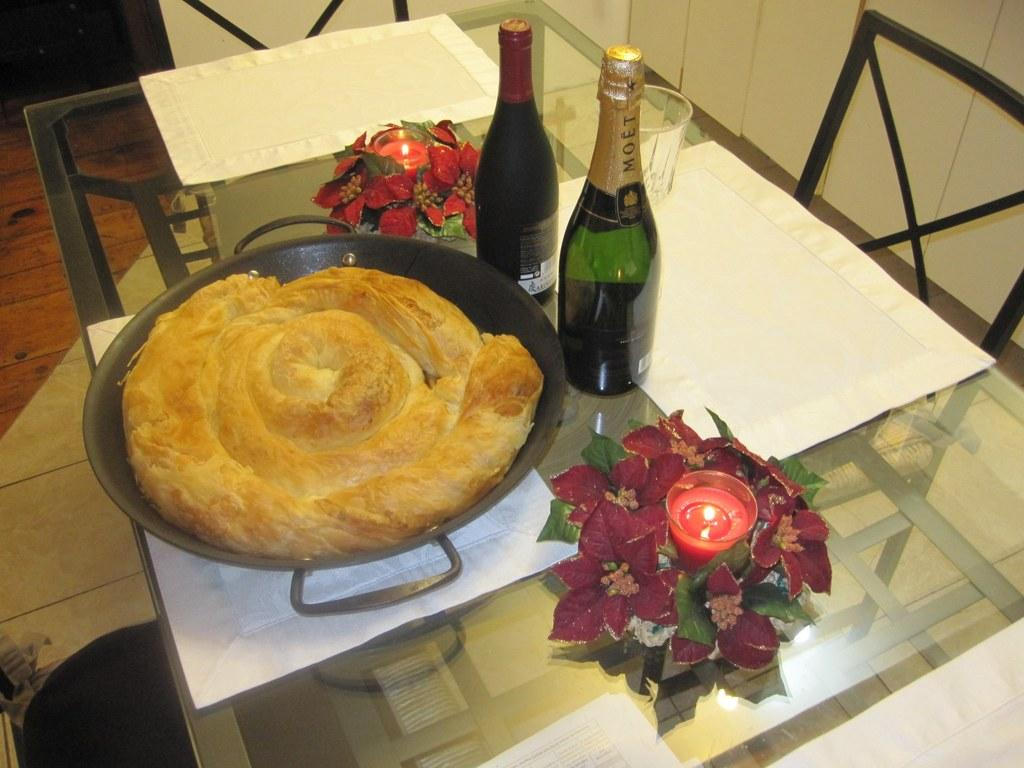What type of beverage containers are on the table in the image? There are wine bottles on the table in the image. What other items can be seen on the table? There are candles, a glass, a flower vase, and food in a bowl on the table. What can be seen in the background of the image? In the background, there is a floor, a wall, and chairs. How many boats are visible in the image? There are no boats present in the image. What type of pie is being served on the table? There is no pie visible in the image; instead, there is food in a bowl on the table. 